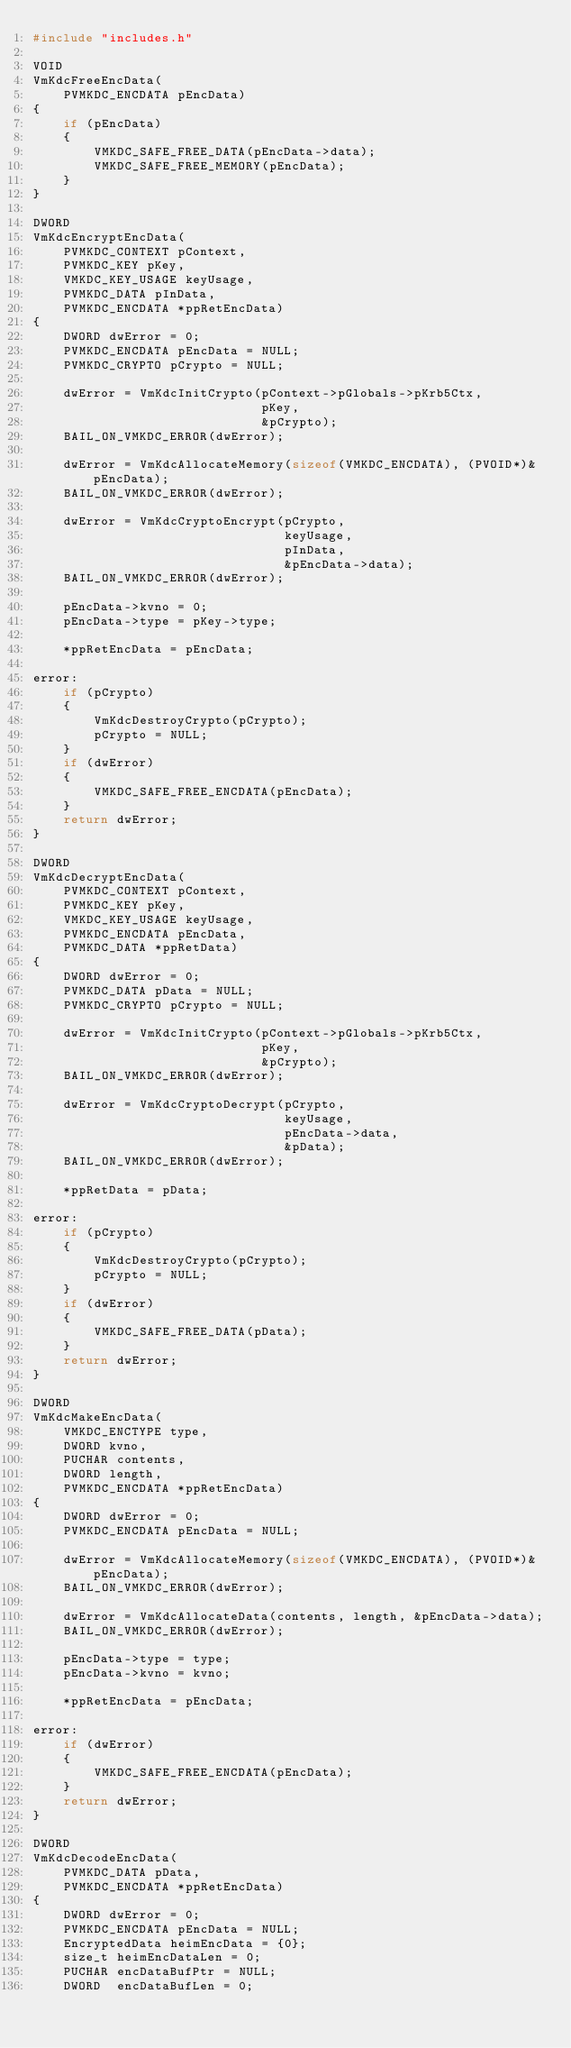<code> <loc_0><loc_0><loc_500><loc_500><_C_>#include "includes.h"

VOID
VmKdcFreeEncData(
    PVMKDC_ENCDATA pEncData)
{
    if (pEncData)
    {
        VMKDC_SAFE_FREE_DATA(pEncData->data);
        VMKDC_SAFE_FREE_MEMORY(pEncData);
    }
}

DWORD
VmKdcEncryptEncData(
    PVMKDC_CONTEXT pContext,
    PVMKDC_KEY pKey,
    VMKDC_KEY_USAGE keyUsage,
    PVMKDC_DATA pInData,
    PVMKDC_ENCDATA *ppRetEncData)
{
    DWORD dwError = 0;
    PVMKDC_ENCDATA pEncData = NULL;
    PVMKDC_CRYPTO pCrypto = NULL;

    dwError = VmKdcInitCrypto(pContext->pGlobals->pKrb5Ctx,
                              pKey,
                              &pCrypto);
    BAIL_ON_VMKDC_ERROR(dwError);

    dwError = VmKdcAllocateMemory(sizeof(VMKDC_ENCDATA), (PVOID*)&pEncData);
    BAIL_ON_VMKDC_ERROR(dwError);

    dwError = VmKdcCryptoEncrypt(pCrypto,
                                 keyUsage,
                                 pInData,
                                 &pEncData->data);
    BAIL_ON_VMKDC_ERROR(dwError);

    pEncData->kvno = 0;
    pEncData->type = pKey->type;

    *ppRetEncData = pEncData;

error:
    if (pCrypto)
    {
        VmKdcDestroyCrypto(pCrypto);
        pCrypto = NULL;
    }
    if (dwError)
    {
        VMKDC_SAFE_FREE_ENCDATA(pEncData);
    }
    return dwError;
}

DWORD
VmKdcDecryptEncData(
    PVMKDC_CONTEXT pContext,
    PVMKDC_KEY pKey,
    VMKDC_KEY_USAGE keyUsage,
    PVMKDC_ENCDATA pEncData,
    PVMKDC_DATA *ppRetData)
{
    DWORD dwError = 0;
    PVMKDC_DATA pData = NULL;
    PVMKDC_CRYPTO pCrypto = NULL;

    dwError = VmKdcInitCrypto(pContext->pGlobals->pKrb5Ctx,
                              pKey,
                              &pCrypto);
    BAIL_ON_VMKDC_ERROR(dwError);

    dwError = VmKdcCryptoDecrypt(pCrypto,
                                 keyUsage,
                                 pEncData->data,
                                 &pData);
    BAIL_ON_VMKDC_ERROR(dwError);

    *ppRetData = pData;

error:
    if (pCrypto)
    {
        VmKdcDestroyCrypto(pCrypto);
        pCrypto = NULL;
    }
    if (dwError)
    {
        VMKDC_SAFE_FREE_DATA(pData);
    }
    return dwError;
}

DWORD
VmKdcMakeEncData(
    VMKDC_ENCTYPE type,
    DWORD kvno,
    PUCHAR contents,
    DWORD length,
    PVMKDC_ENCDATA *ppRetEncData)
{
    DWORD dwError = 0;
    PVMKDC_ENCDATA pEncData = NULL;

    dwError = VmKdcAllocateMemory(sizeof(VMKDC_ENCDATA), (PVOID*)&pEncData);
    BAIL_ON_VMKDC_ERROR(dwError);

    dwError = VmKdcAllocateData(contents, length, &pEncData->data);
    BAIL_ON_VMKDC_ERROR(dwError);

    pEncData->type = type;
    pEncData->kvno = kvno;

    *ppRetEncData = pEncData;

error:
    if (dwError)
    {
        VMKDC_SAFE_FREE_ENCDATA(pEncData);
    }
    return dwError;
}

DWORD
VmKdcDecodeEncData(
    PVMKDC_DATA pData,
    PVMKDC_ENCDATA *ppRetEncData)
{
    DWORD dwError = 0;
    PVMKDC_ENCDATA pEncData = NULL;
    EncryptedData heimEncData = {0};
    size_t heimEncDataLen = 0;
    PUCHAR encDataBufPtr = NULL;
    DWORD  encDataBufLen = 0;
</code> 